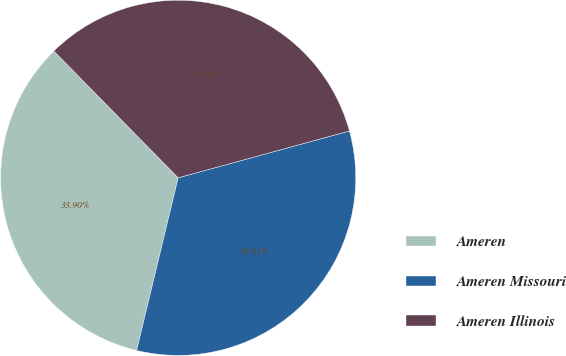<chart> <loc_0><loc_0><loc_500><loc_500><pie_chart><fcel>Ameren<fcel>Ameren Missouri<fcel>Ameren Illinois<nl><fcel>33.9%<fcel>33.01%<fcel>33.1%<nl></chart> 